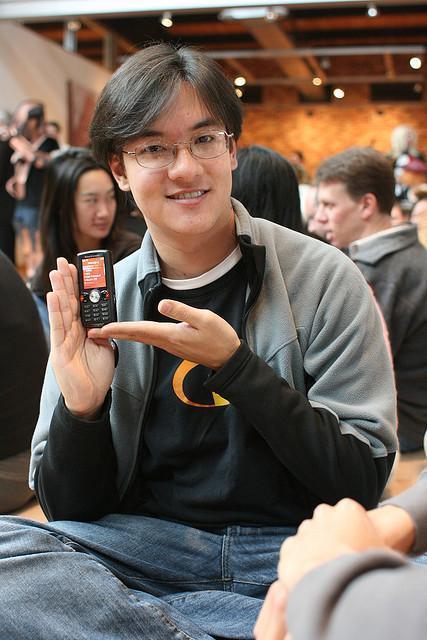How many people are visible?
Give a very brief answer. 6. 